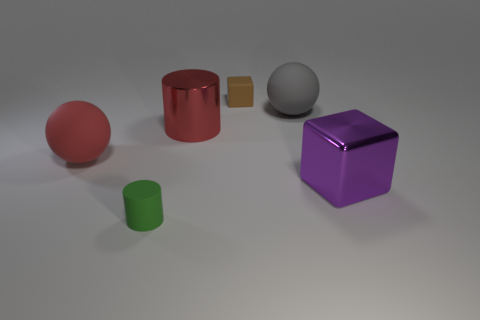Add 4 green objects. How many objects exist? 10 Subtract all cylinders. How many objects are left? 4 Subtract all gray cubes. Subtract all red balls. How many cubes are left? 2 Subtract all cyan spheres. How many brown cubes are left? 1 Subtract 0 blue blocks. How many objects are left? 6 Subtract all small purple things. Subtract all large metal cubes. How many objects are left? 5 Add 4 tiny cylinders. How many tiny cylinders are left? 5 Add 5 large purple metallic blocks. How many large purple metallic blocks exist? 6 